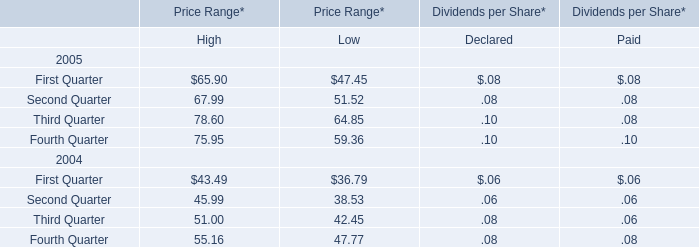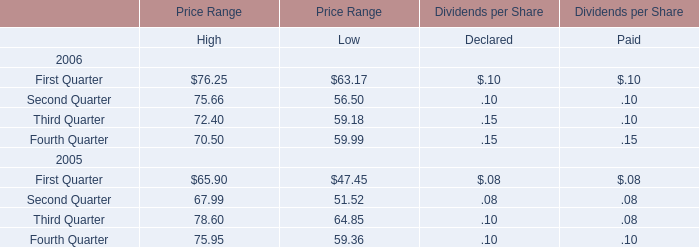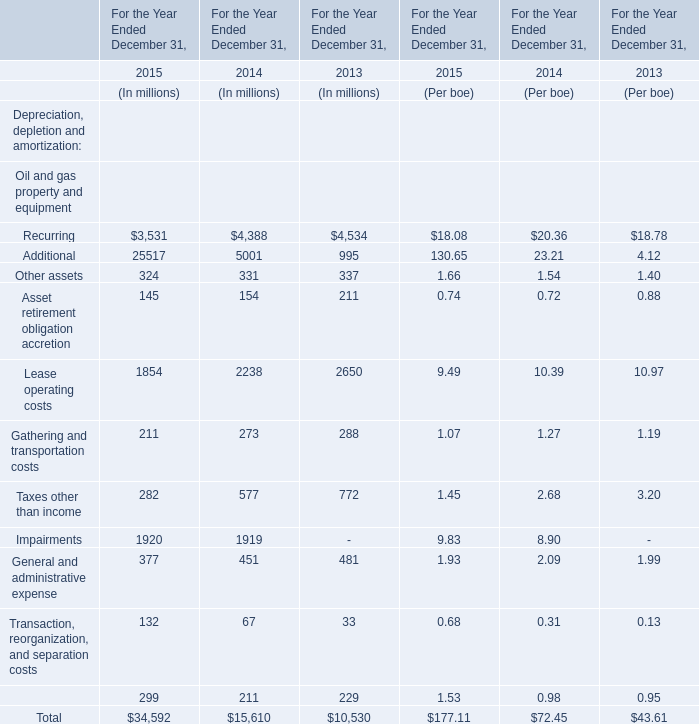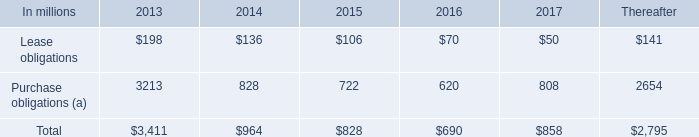what was the average rent expense from 2010 to 2012 \\n 
Computations: (((210 + (231 + 205)) + 3) / 2)
Answer: 324.5. 